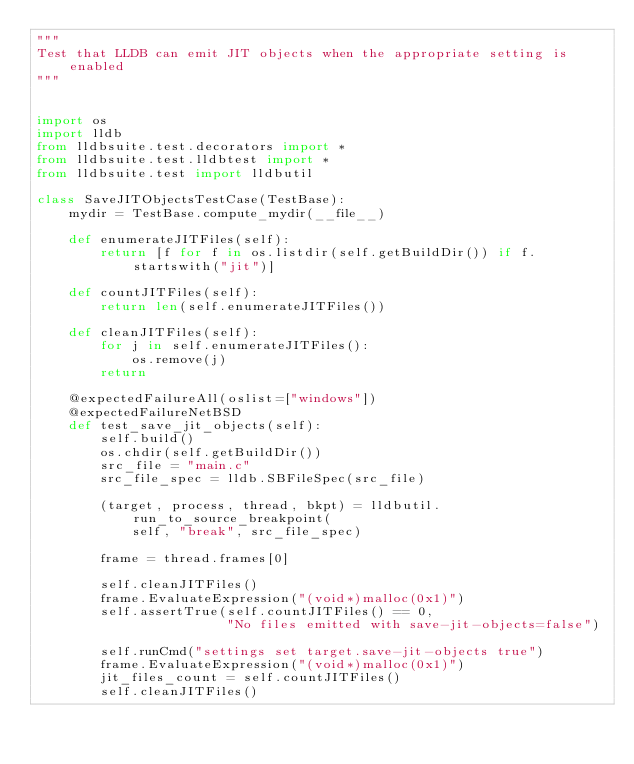<code> <loc_0><loc_0><loc_500><loc_500><_Python_>"""
Test that LLDB can emit JIT objects when the appropriate setting is enabled
"""


import os
import lldb
from lldbsuite.test.decorators import *
from lldbsuite.test.lldbtest import *
from lldbsuite.test import lldbutil

class SaveJITObjectsTestCase(TestBase):
    mydir = TestBase.compute_mydir(__file__)

    def enumerateJITFiles(self):
        return [f for f in os.listdir(self.getBuildDir()) if f.startswith("jit")]

    def countJITFiles(self):
        return len(self.enumerateJITFiles())

    def cleanJITFiles(self):
        for j in self.enumerateJITFiles():
            os.remove(j)
        return

    @expectedFailureAll(oslist=["windows"])
    @expectedFailureNetBSD
    def test_save_jit_objects(self):
        self.build()
        os.chdir(self.getBuildDir())
        src_file = "main.c"
        src_file_spec = lldb.SBFileSpec(src_file)

        (target, process, thread, bkpt) = lldbutil.run_to_source_breakpoint(
            self, "break", src_file_spec)

        frame = thread.frames[0]

        self.cleanJITFiles()
        frame.EvaluateExpression("(void*)malloc(0x1)")
        self.assertTrue(self.countJITFiles() == 0,
                        "No files emitted with save-jit-objects=false")

        self.runCmd("settings set target.save-jit-objects true")
        frame.EvaluateExpression("(void*)malloc(0x1)")
        jit_files_count = self.countJITFiles()
        self.cleanJITFiles()</code> 